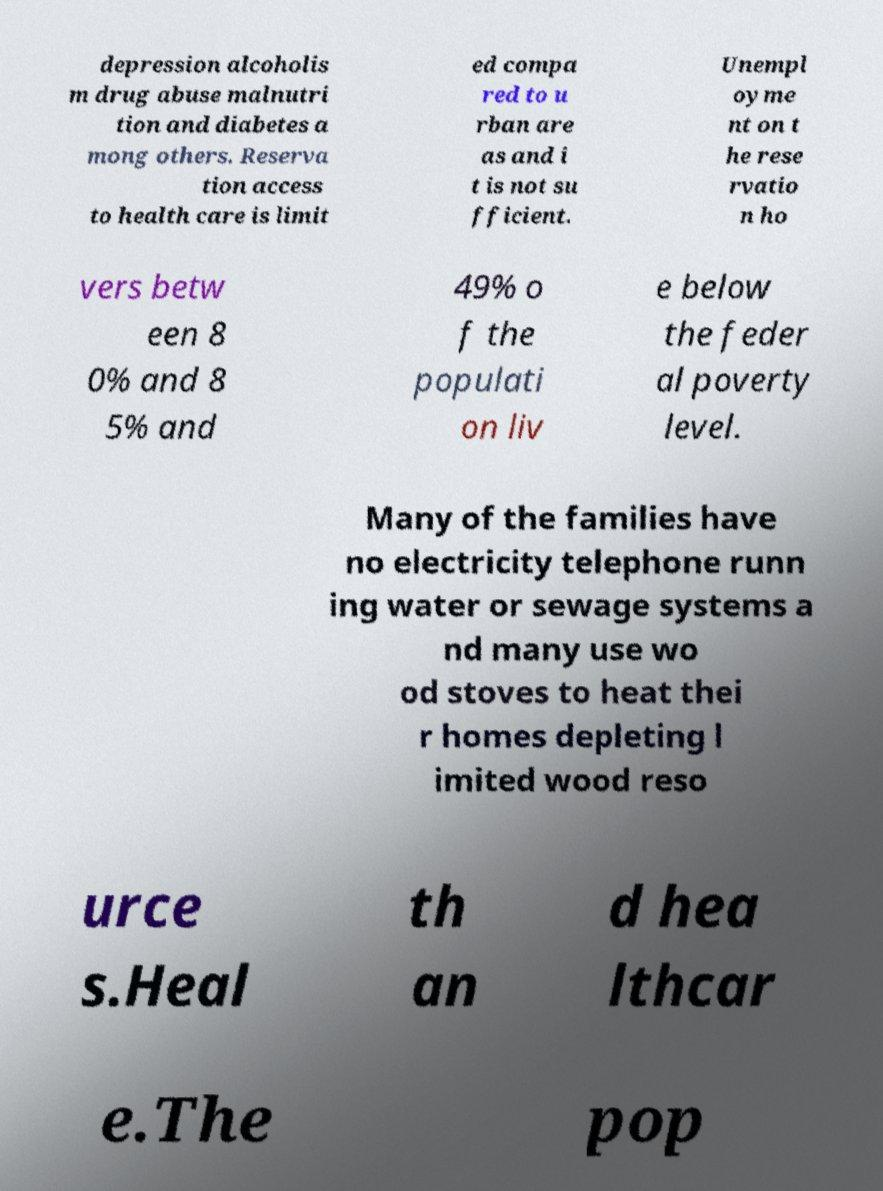There's text embedded in this image that I need extracted. Can you transcribe it verbatim? depression alcoholis m drug abuse malnutri tion and diabetes a mong others. Reserva tion access to health care is limit ed compa red to u rban are as and i t is not su fficient. Unempl oyme nt on t he rese rvatio n ho vers betw een 8 0% and 8 5% and 49% o f the populati on liv e below the feder al poverty level. Many of the families have no electricity telephone runn ing water or sewage systems a nd many use wo od stoves to heat thei r homes depleting l imited wood reso urce s.Heal th an d hea lthcar e.The pop 